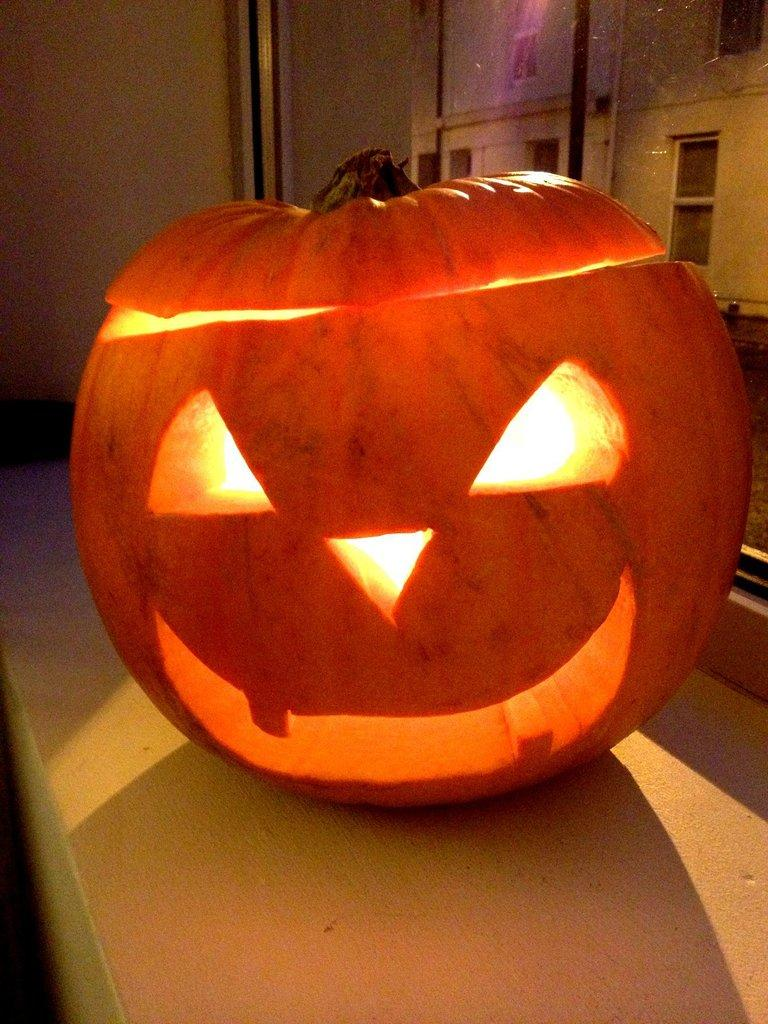What is the main object in the image? There is a pumpkin in the image. What else can be seen in the image besides the pumpkin? There is a building in the image. How many cows are grazing near the pumpkin in the image? There are no cows present in the image; it only features a pumpkin and a building. 